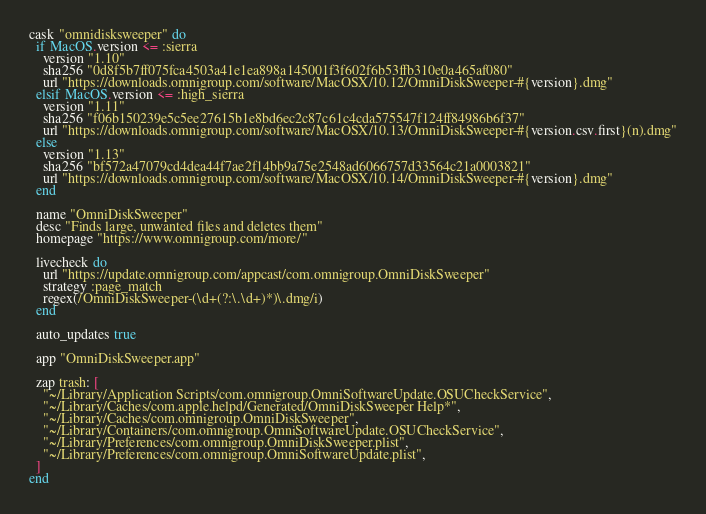<code> <loc_0><loc_0><loc_500><loc_500><_Ruby_>cask "omnidisksweeper" do
  if MacOS.version <= :sierra
    version "1.10"
    sha256 "0d8f5b7ff075fca4503a41e1ea898a145001f3f602f6b53ffb310e0a465af080"
    url "https://downloads.omnigroup.com/software/MacOSX/10.12/OmniDiskSweeper-#{version}.dmg"
  elsif MacOS.version <= :high_sierra
    version "1.11"
    sha256 "f06b150239e5c5ee27615b1e8bd6ec2c87c61c4cda575547f124ff84986b6f37"
    url "https://downloads.omnigroup.com/software/MacOSX/10.13/OmniDiskSweeper-#{version.csv.first}(n).dmg"
  else
    version "1.13"
    sha256 "bf572a47079cd4dea44f7ae2f14bb9a75e2548ad6066757d33564c21a0003821"
    url "https://downloads.omnigroup.com/software/MacOSX/10.14/OmniDiskSweeper-#{version}.dmg"
  end

  name "OmniDiskSweeper"
  desc "Finds large, unwanted files and deletes them"
  homepage "https://www.omnigroup.com/more/"

  livecheck do
    url "https://update.omnigroup.com/appcast/com.omnigroup.OmniDiskSweeper"
    strategy :page_match
    regex(/OmniDiskSweeper-(\d+(?:\.\d+)*)\.dmg/i)
  end

  auto_updates true

  app "OmniDiskSweeper.app"

  zap trash: [
    "~/Library/Application Scripts/com.omnigroup.OmniSoftwareUpdate.OSUCheckService",
    "~/Library/Caches/com.apple.helpd/Generated/OmniDiskSweeper Help*",
    "~/Library/Caches/com.omnigroup.OmniDiskSweeper",
    "~/Library/Containers/com.omnigroup.OmniSoftwareUpdate.OSUCheckService",
    "~/Library/Preferences/com.omnigroup.OmniDiskSweeper.plist",
    "~/Library/Preferences/com.omnigroup.OmniSoftwareUpdate.plist",
  ]
end
</code> 